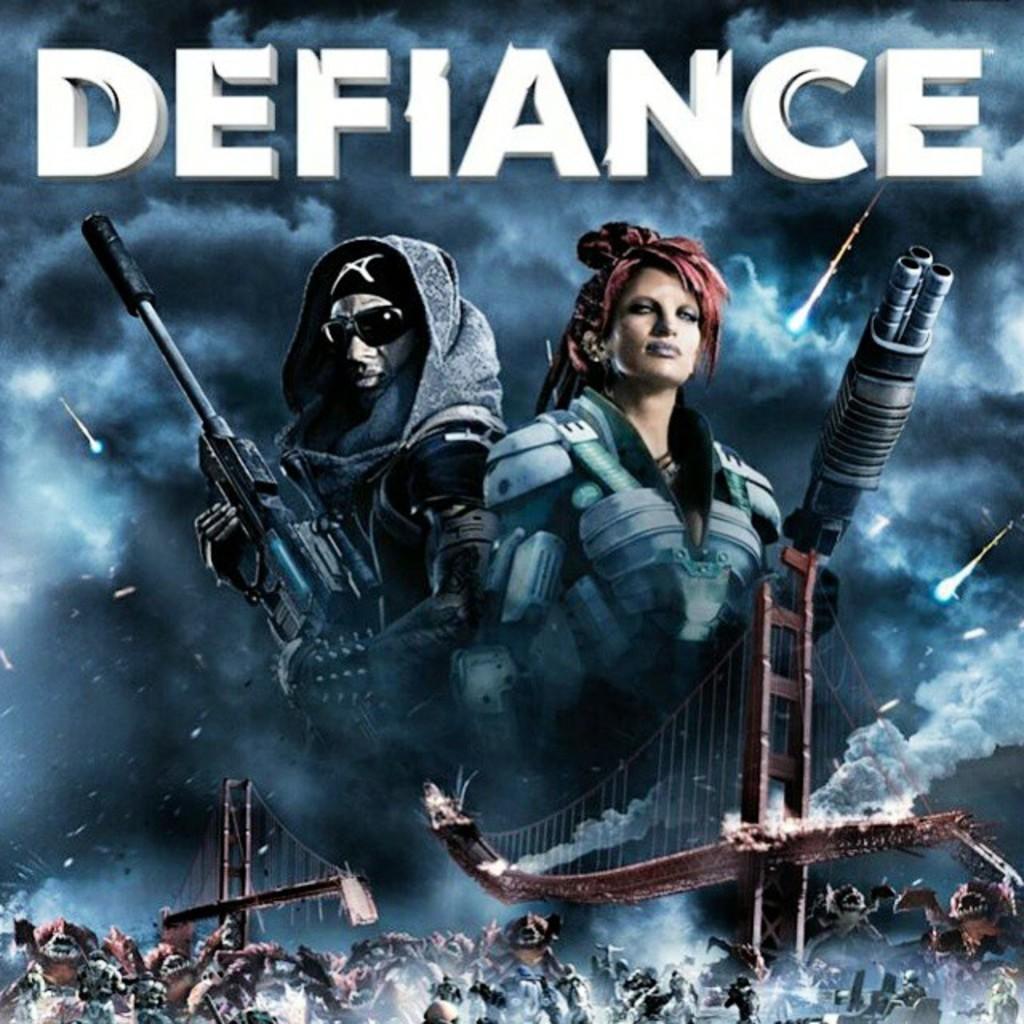How would you summarize this image in a sentence or two? This is an animated image. In the center we can see the two persons holding the weapons and in the foreground we can see the group of persons, metal rods and some other objects. At the top we can see the text. In the background we can see the sky, clouds and some objects in the sky. 